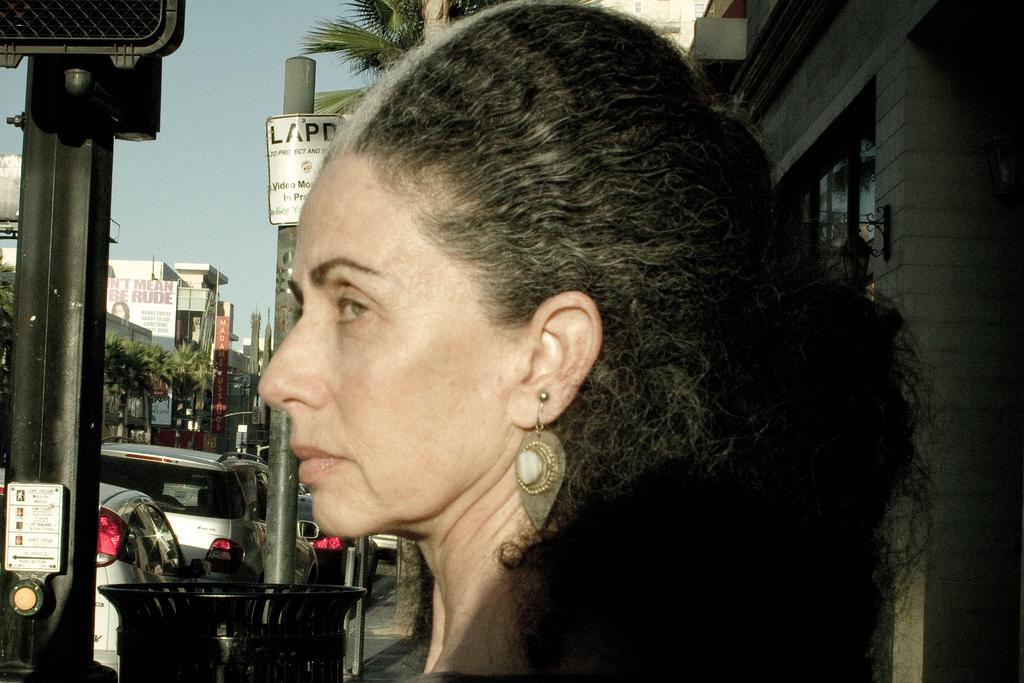Can you describe this image briefly? In this image I can see the person. In the background I can see few vehicles, stalls, trees, buildings, poles and the sky is in blue color. 